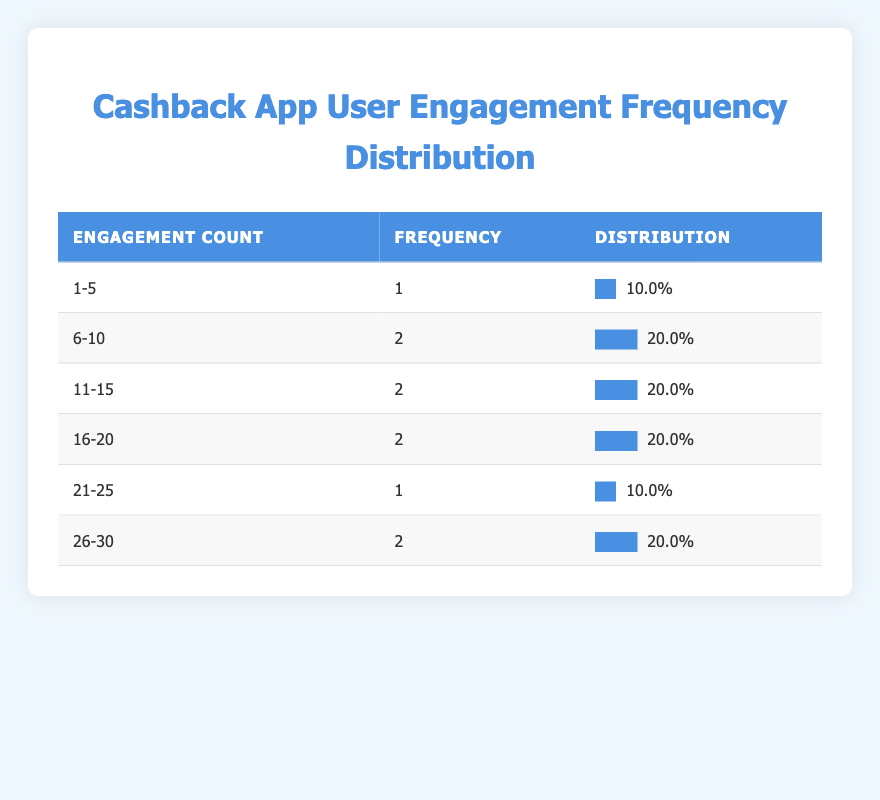What is the highest engagement count range? The highest engagement count range is determined by looking at the table's ranges and their corresponding frequencies. The highest engagement count recorded is 30, which falls into the "26-30" range.
Answer: 26-30 How many users engaged between 11 and 15 times? From the table, the range "11-15" has a frequency of 3. This indicates that 3 users fall within this engagement count bracket.
Answer: 3 What percentage of users engaged 10 times or less? To find this percentage, we first identify the frequencies for the ranges "1-5" (1 user) and "6-10" (2 users), which totals 3 users. We then divide this by the total number of users (10) and multiply by 100 to get the percentage: (3/10) * 100 = 30%.
Answer: 30% What is the total frequency of users who engaged more than 20 times? The ranges that correspond to users engaging more than 20 times are "21-25" (1 user) and "26-30" (1 user). Summing these gives us a total frequency of 2 users.
Answer: 2 Is it true that more than 50% of users engaged 15 times or less? To evaluate this, we check the total number of users who engaged 15 times or less, which is the sum of the frequencies for the ranges "1-5" (1), "6-10" (2), "11-15" (3) totaling 6 users. Dividing this by the total 10 users gives us 60%, confirming that it is, indeed, true.
Answer: Yes What is the average engagement count among the users? To find the average, we calculate the total engagement count: (1*3 + 6*2 + 11*3 + 16*2 + 21*1 + 26*1), which equals 112. Dividing this by the number of users (10) gives an average of 11.2.
Answer: 11.2 How many users engaged between 16 and 25 times? The ranges for this are "16-20" (2 users) and "21-25" (1 user). Adding these together gives a total of 3 users who engaged between 16 and 25 times.
Answer: 3 What is the frequency of users engaging 6 to 10 times compared to those engaging 26 to 30 times? The frequency for "6-10" is 2 users, while for "26-30" it is 1 user. Thus, there are more users engaging 6 to 10 times than those engaging 26 to 30 times, specifically 2 to 1.
Answer: 2 to 1 